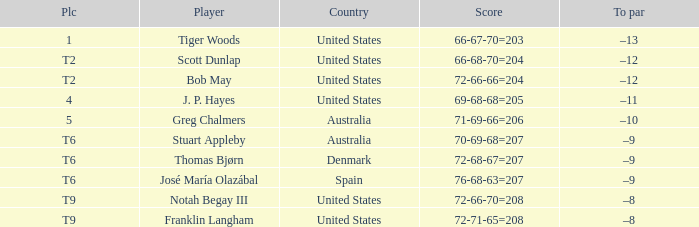Would you mind parsing the complete table? {'header': ['Plc', 'Player', 'Country', 'Score', 'To par'], 'rows': [['1', 'Tiger Woods', 'United States', '66-67-70=203', '–13'], ['T2', 'Scott Dunlap', 'United States', '66-68-70=204', '–12'], ['T2', 'Bob May', 'United States', '72-66-66=204', '–12'], ['4', 'J. P. Hayes', 'United States', '69-68-68=205', '–11'], ['5', 'Greg Chalmers', 'Australia', '71-69-66=206', '–10'], ['T6', 'Stuart Appleby', 'Australia', '70-69-68=207', '–9'], ['T6', 'Thomas Bjørn', 'Denmark', '72-68-67=207', '–9'], ['T6', 'José María Olazábal', 'Spain', '76-68-63=207', '–9'], ['T9', 'Notah Begay III', 'United States', '72-66-70=208', '–8'], ['T9', 'Franklin Langham', 'United States', '72-71-65=208', '–8']]} What is the place of the player with a 66-68-70=204 score? T2. 